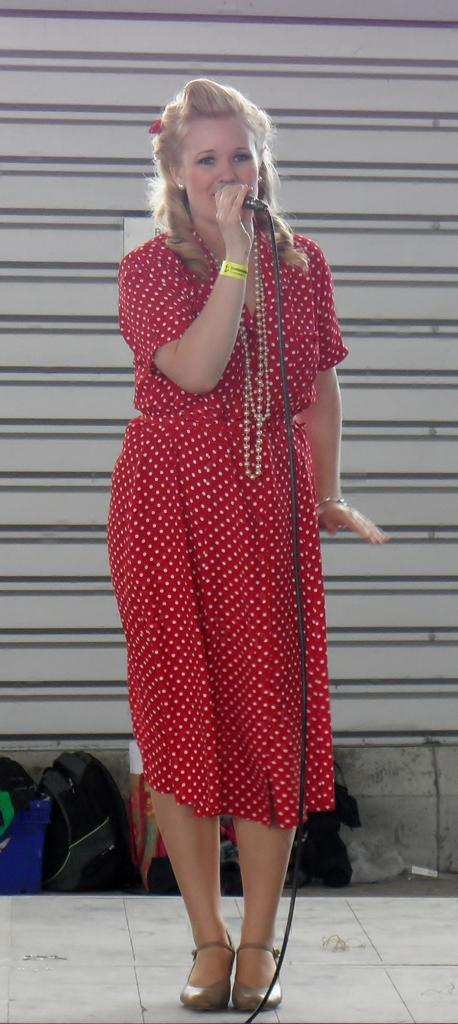Who is the main subject in the image? There is a woman in the image. What is the woman wearing? The woman is wearing a red dress. What is the woman holding in the image? The woman is holding a microphone. What else can be seen in the image besides the woman? There are bags in the image. How many circles can be seen on the woman's dress in the image? There is no mention of circles on the woman's dress in the image; it is described as a red dress. 